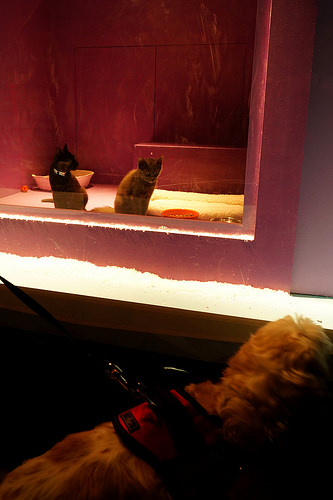<image>
Is there a cat in the leash? No. The cat is not contained within the leash. These objects have a different spatial relationship. 